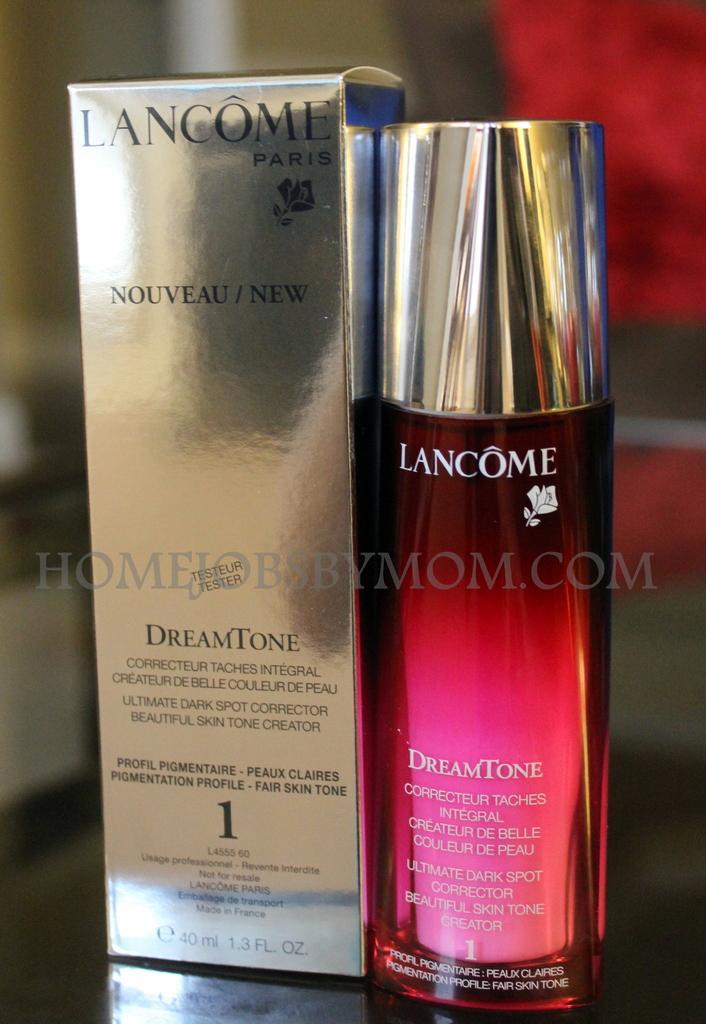In one or two sentences, can you explain what this image depicts? In the image there is a box with text on it. Beside the box there is a bottle with text on it. There is a watermark in the image. And there is a blur background. 